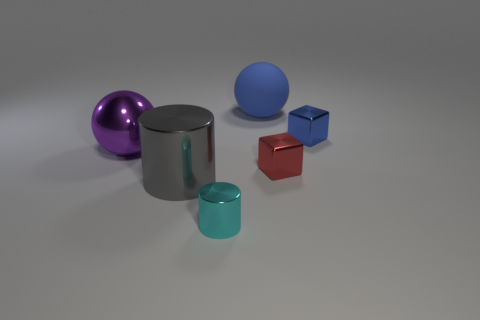What materials do the objects in the image appear to be made from? The objects in the image exhibit a variety of material appearances. The shiny ones, such as the purple and center gray objects, suggest a metallic surface, likely reflecting a simulated environment in a 3D rendering. The red and blue cubes seem to have a more diffuse, possibly plastic-like surface. Lastly, the blue sphere has a matte finish, giving it a soft and possibly rubbery appearance. 